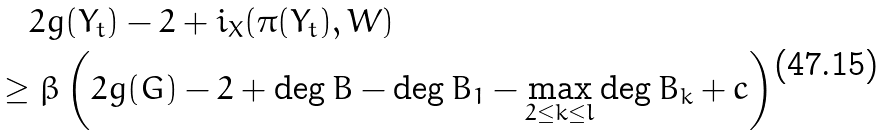<formula> <loc_0><loc_0><loc_500><loc_500>& \quad 2 g ( Y _ { t } ) - 2 + i _ { X } ( \pi ( Y _ { t } ) , W ) \\ & \geq \beta \left ( 2 g ( G ) - 2 + \deg B - \deg B _ { 1 } - \max _ { 2 \leq k \leq l } \deg B _ { k } + c \right )</formula> 